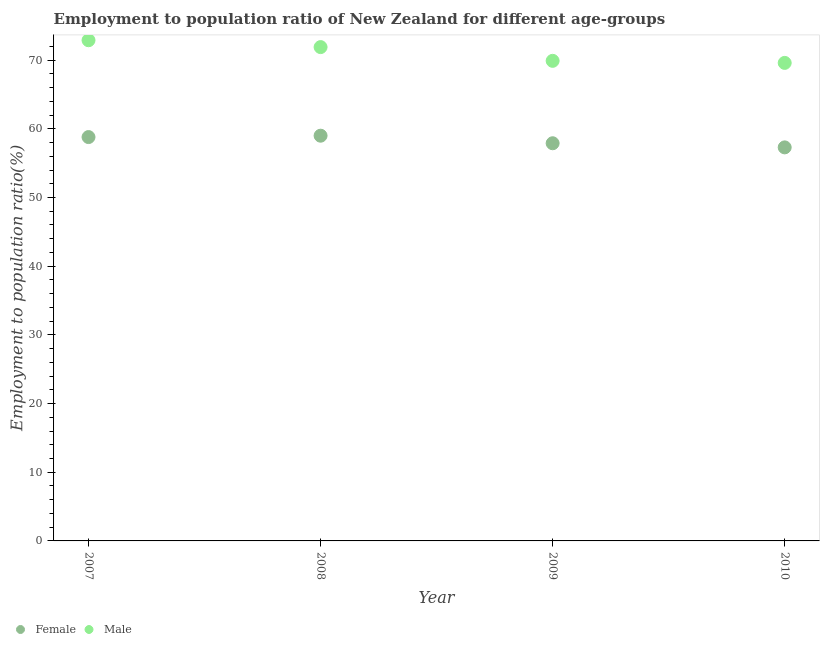How many different coloured dotlines are there?
Offer a terse response. 2. What is the employment to population ratio(female) in 2009?
Provide a short and direct response. 57.9. Across all years, what is the maximum employment to population ratio(female)?
Your answer should be very brief. 59. Across all years, what is the minimum employment to population ratio(female)?
Provide a short and direct response. 57.3. In which year was the employment to population ratio(male) maximum?
Offer a terse response. 2007. In which year was the employment to population ratio(male) minimum?
Your answer should be very brief. 2010. What is the total employment to population ratio(male) in the graph?
Offer a very short reply. 284.3. What is the difference between the employment to population ratio(female) in 2009 and that in 2010?
Your response must be concise. 0.6. What is the difference between the employment to population ratio(male) in 2007 and the employment to population ratio(female) in 2008?
Offer a terse response. 13.9. What is the average employment to population ratio(female) per year?
Ensure brevity in your answer.  58.25. In the year 2008, what is the difference between the employment to population ratio(male) and employment to population ratio(female)?
Your answer should be compact. 12.9. What is the ratio of the employment to population ratio(male) in 2008 to that in 2009?
Give a very brief answer. 1.03. Is the employment to population ratio(male) in 2008 less than that in 2010?
Provide a succinct answer. No. Is the difference between the employment to population ratio(female) in 2008 and 2009 greater than the difference between the employment to population ratio(male) in 2008 and 2009?
Your response must be concise. No. What is the difference between the highest and the second highest employment to population ratio(female)?
Offer a very short reply. 0.2. What is the difference between the highest and the lowest employment to population ratio(male)?
Give a very brief answer. 3.3. Does the employment to population ratio(male) monotonically increase over the years?
Your answer should be very brief. No. How many legend labels are there?
Ensure brevity in your answer.  2. What is the title of the graph?
Offer a terse response. Employment to population ratio of New Zealand for different age-groups. Does "Primary" appear as one of the legend labels in the graph?
Provide a succinct answer. No. What is the Employment to population ratio(%) in Female in 2007?
Provide a succinct answer. 58.8. What is the Employment to population ratio(%) of Male in 2007?
Make the answer very short. 72.9. What is the Employment to population ratio(%) in Male in 2008?
Make the answer very short. 71.9. What is the Employment to population ratio(%) of Female in 2009?
Offer a very short reply. 57.9. What is the Employment to population ratio(%) of Male in 2009?
Ensure brevity in your answer.  69.9. What is the Employment to population ratio(%) of Female in 2010?
Your response must be concise. 57.3. What is the Employment to population ratio(%) in Male in 2010?
Provide a short and direct response. 69.6. Across all years, what is the maximum Employment to population ratio(%) of Male?
Give a very brief answer. 72.9. Across all years, what is the minimum Employment to population ratio(%) in Female?
Your response must be concise. 57.3. Across all years, what is the minimum Employment to population ratio(%) in Male?
Give a very brief answer. 69.6. What is the total Employment to population ratio(%) in Female in the graph?
Your response must be concise. 233. What is the total Employment to population ratio(%) of Male in the graph?
Offer a very short reply. 284.3. What is the difference between the Employment to population ratio(%) of Female in 2007 and that in 2008?
Give a very brief answer. -0.2. What is the difference between the Employment to population ratio(%) in Male in 2007 and that in 2008?
Provide a short and direct response. 1. What is the difference between the Employment to population ratio(%) of Female in 2007 and that in 2009?
Keep it short and to the point. 0.9. What is the difference between the Employment to population ratio(%) of Male in 2007 and that in 2009?
Provide a succinct answer. 3. What is the difference between the Employment to population ratio(%) of Female in 2007 and that in 2010?
Your answer should be very brief. 1.5. What is the difference between the Employment to population ratio(%) in Male in 2007 and that in 2010?
Your answer should be compact. 3.3. What is the difference between the Employment to population ratio(%) in Male in 2008 and that in 2009?
Provide a succinct answer. 2. What is the difference between the Employment to population ratio(%) of Male in 2008 and that in 2010?
Ensure brevity in your answer.  2.3. What is the difference between the Employment to population ratio(%) in Male in 2009 and that in 2010?
Offer a very short reply. 0.3. What is the difference between the Employment to population ratio(%) in Female in 2007 and the Employment to population ratio(%) in Male in 2009?
Ensure brevity in your answer.  -11.1. What is the difference between the Employment to population ratio(%) in Female in 2007 and the Employment to population ratio(%) in Male in 2010?
Provide a succinct answer. -10.8. What is the average Employment to population ratio(%) in Female per year?
Make the answer very short. 58.25. What is the average Employment to population ratio(%) in Male per year?
Ensure brevity in your answer.  71.08. In the year 2007, what is the difference between the Employment to population ratio(%) in Female and Employment to population ratio(%) in Male?
Your answer should be compact. -14.1. In the year 2008, what is the difference between the Employment to population ratio(%) in Female and Employment to population ratio(%) in Male?
Give a very brief answer. -12.9. In the year 2009, what is the difference between the Employment to population ratio(%) of Female and Employment to population ratio(%) of Male?
Keep it short and to the point. -12. In the year 2010, what is the difference between the Employment to population ratio(%) in Female and Employment to population ratio(%) in Male?
Offer a very short reply. -12.3. What is the ratio of the Employment to population ratio(%) of Male in 2007 to that in 2008?
Ensure brevity in your answer.  1.01. What is the ratio of the Employment to population ratio(%) of Female in 2007 to that in 2009?
Keep it short and to the point. 1.02. What is the ratio of the Employment to population ratio(%) of Male in 2007 to that in 2009?
Provide a short and direct response. 1.04. What is the ratio of the Employment to population ratio(%) in Female in 2007 to that in 2010?
Your response must be concise. 1.03. What is the ratio of the Employment to population ratio(%) of Male in 2007 to that in 2010?
Provide a short and direct response. 1.05. What is the ratio of the Employment to population ratio(%) of Male in 2008 to that in 2009?
Your response must be concise. 1.03. What is the ratio of the Employment to population ratio(%) in Female in 2008 to that in 2010?
Your answer should be very brief. 1.03. What is the ratio of the Employment to population ratio(%) in Male in 2008 to that in 2010?
Keep it short and to the point. 1.03. What is the ratio of the Employment to population ratio(%) of Female in 2009 to that in 2010?
Your answer should be compact. 1.01. What is the difference between the highest and the second highest Employment to population ratio(%) in Female?
Ensure brevity in your answer.  0.2. What is the difference between the highest and the second highest Employment to population ratio(%) of Male?
Provide a short and direct response. 1. 